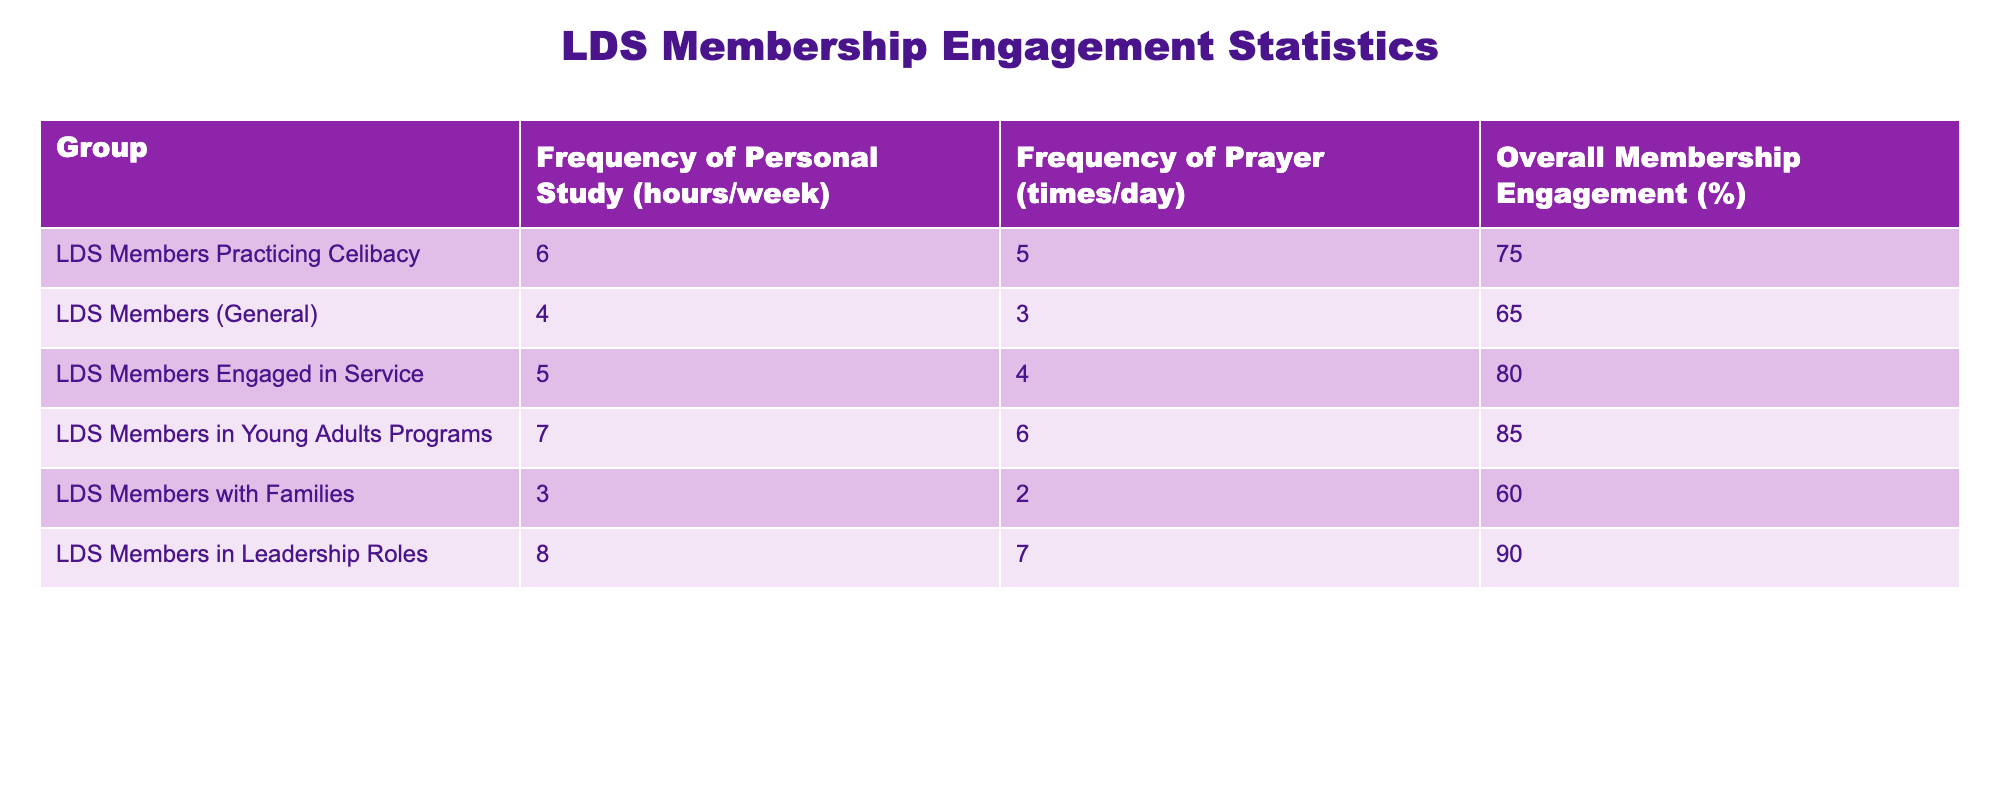What is the frequency of personal study among LDS members practicing celibacy? The table indicates that LDS members practicing celibacy dedicate 6 hours per week to personal study.
Answer: 6 hours/week What is the frequency of prayer among overall LDS members? According to the table, the overall frequency of prayer among LDS members is 3 times per day.
Answer: 3 times/day Which group engages in personal study the most, and how many hours do they study? By comparing the frequencies in the table, LDS members in Young Adults Programs engage in personal study the most, with 7 hours per week.
Answer: Young Adults Programs, 7 hours/week Is the frequency of prayer higher for LDS members practicing celibacy compared to the general membership? The frequency of prayer for LDS members practicing celibacy is 5 times per day, while for the general membership, it is 3 times per day. This shows that practicing celibacy members pray more frequently.
Answer: Yes What is the difference in the overall membership engagement percentage between LDS members engaged in service and those practicing celibacy? The overall membership engagement for members engaged in service is 80%, and for those practicing celibacy is 75%. Therefore, the difference is 80% - 75% = 5%.
Answer: 5% What is the average frequency of personal study for all groups listed in the table? To calculate the average frequency of personal study, add all the hours of each group: (6 + 4 + 5 + 7 + 3 + 8) = 33 hours. There are 6 groups, so the average is 33/6 = 5.5 hours per week.
Answer: 5.5 hours/week Is the frequency of prayer among LDS members in leadership roles the highest? Looking at the table, LDS members in leadership roles pray 7 times per day, which is the highest frequency when comparing all groups listed in the table.
Answer: Yes What percentage of overall membership engagement do LDS members with families have? The table shows that LDS members with families have an overall membership engagement of 60%.
Answer: 60% How do the frequencies of personal study between those practicing celibacy and those in leadership roles differ? LDS members practicing celibacy study for 6 hours per week while those in leadership roles study for 8 hours per week. The difference is 8 - 6 = 2 hours, indicating that leadership members study 2 hours more.
Answer: 2 hours difference 